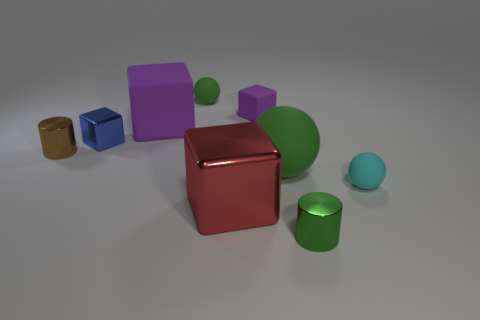What number of other objects are the same color as the small shiny block?
Offer a terse response. 0. The matte cube that is left of the green ball that is behind the cylinder that is to the left of the large rubber ball is what color?
Give a very brief answer. Purple. Is the number of red blocks right of the tiny purple block the same as the number of big green matte things?
Offer a terse response. No. There is a shiny cube to the left of the red metallic cube; is its size the same as the small brown metal thing?
Your answer should be very brief. Yes. What number of cyan spheres are there?
Your answer should be very brief. 1. What number of objects are to the left of the red object and behind the tiny brown shiny thing?
Your answer should be very brief. 3. Is there another object that has the same material as the brown thing?
Provide a short and direct response. Yes. There is a tiny cylinder that is on the right side of the metal block left of the red block; what is its material?
Provide a succinct answer. Metal. Are there the same number of tiny blue metallic things that are behind the tiny matte cube and large shiny things behind the cyan rubber sphere?
Your response must be concise. Yes. Is the shape of the brown thing the same as the cyan matte object?
Provide a short and direct response. No. 